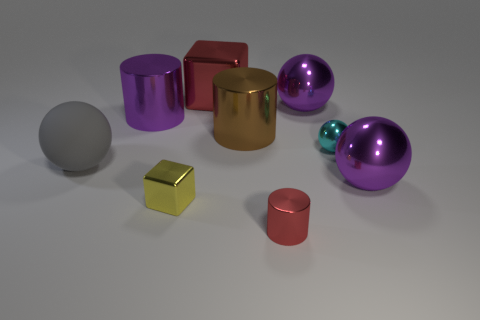Add 1 purple metal things. How many objects exist? 10 Subtract all cubes. How many objects are left? 7 Add 9 tiny metallic cylinders. How many tiny metallic cylinders exist? 10 Subtract 1 purple cylinders. How many objects are left? 8 Subtract all small green spheres. Subtract all large red objects. How many objects are left? 8 Add 5 small cyan objects. How many small cyan objects are left? 6 